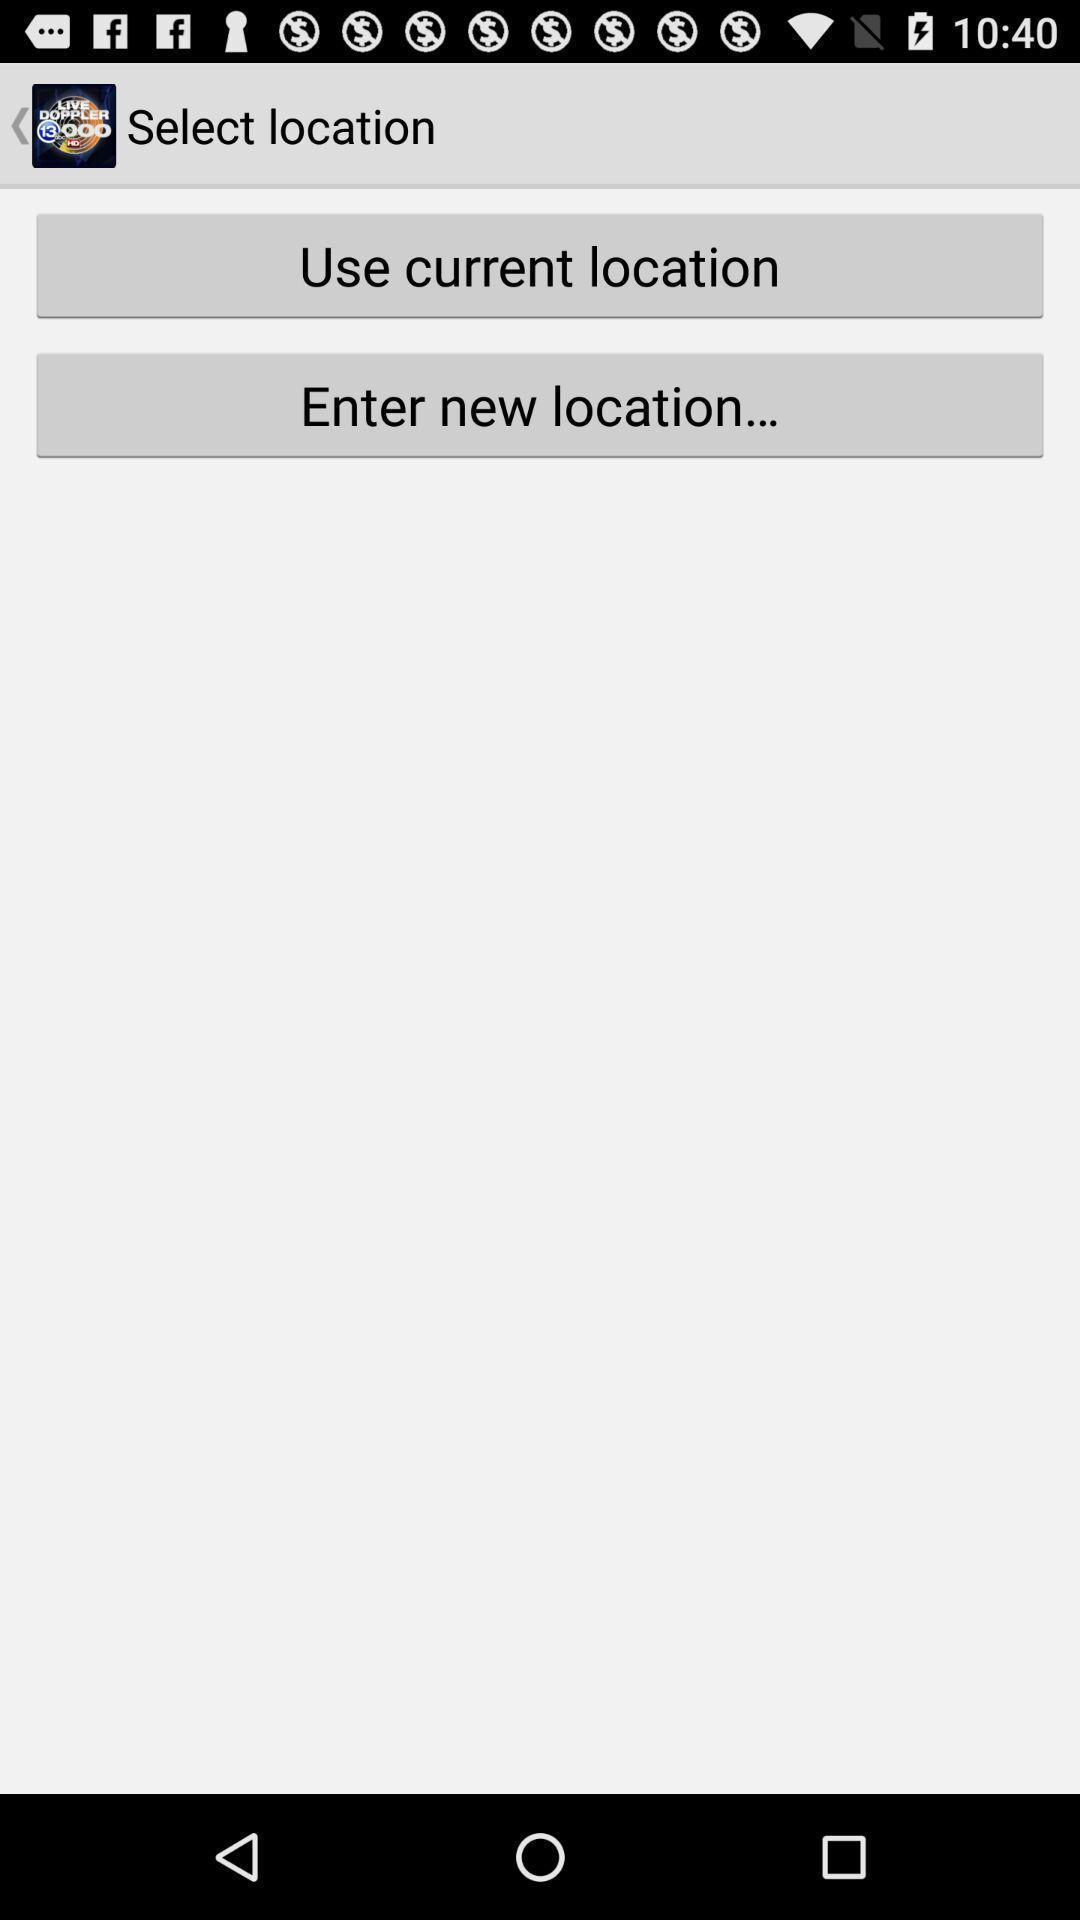Tell me what you see in this picture. Two options to select location. 